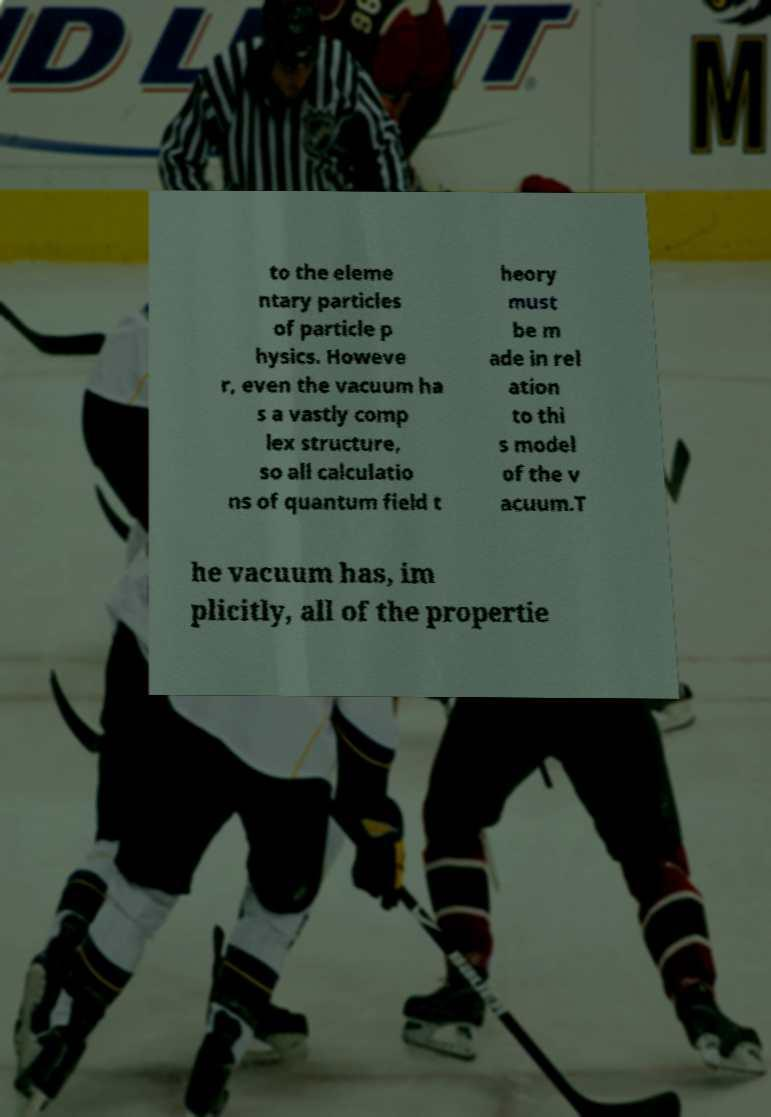There's text embedded in this image that I need extracted. Can you transcribe it verbatim? to the eleme ntary particles of particle p hysics. Howeve r, even the vacuum ha s a vastly comp lex structure, so all calculatio ns of quantum field t heory must be m ade in rel ation to thi s model of the v acuum.T he vacuum has, im plicitly, all of the propertie 